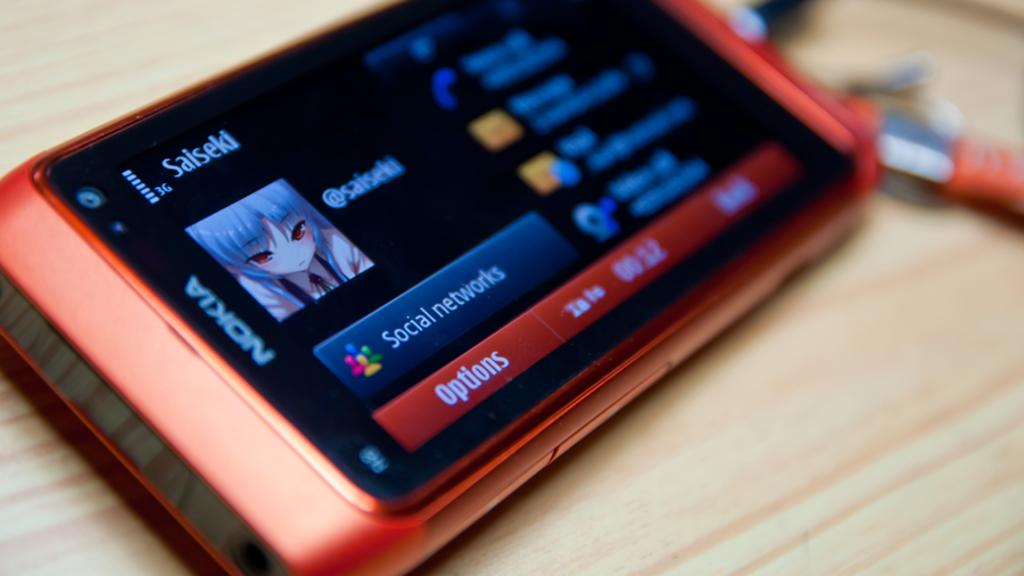<image>
Summarize the visual content of the image. a nokia phone with the options bar open at the bottom 